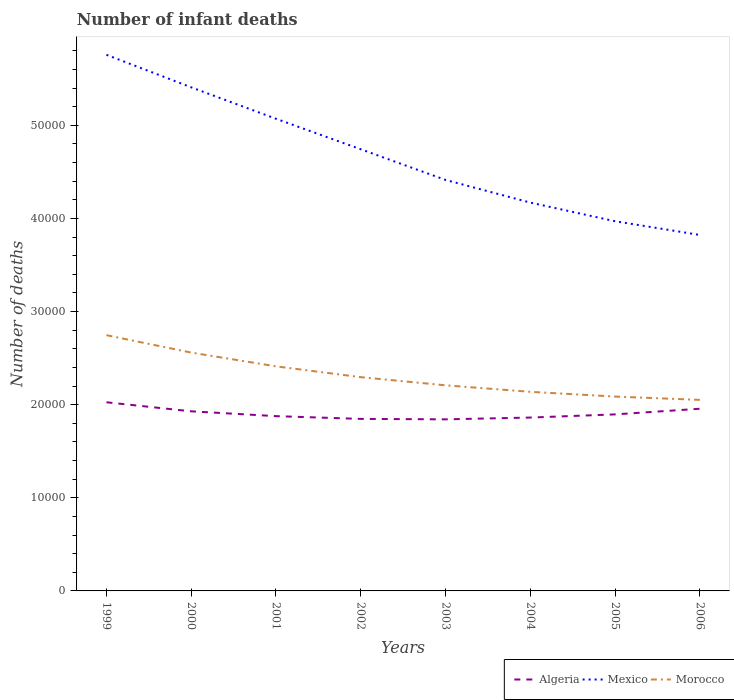How many different coloured lines are there?
Provide a succinct answer. 3. Is the number of lines equal to the number of legend labels?
Your answer should be compact. Yes. Across all years, what is the maximum number of infant deaths in Morocco?
Keep it short and to the point. 2.05e+04. What is the total number of infant deaths in Mexico in the graph?
Provide a short and direct response. 1.59e+04. What is the difference between the highest and the second highest number of infant deaths in Mexico?
Offer a very short reply. 1.93e+04. What is the difference between the highest and the lowest number of infant deaths in Morocco?
Ensure brevity in your answer.  3. How many lines are there?
Provide a short and direct response. 3. What is the difference between two consecutive major ticks on the Y-axis?
Offer a very short reply. 10000. Does the graph contain grids?
Ensure brevity in your answer.  No. How many legend labels are there?
Provide a short and direct response. 3. How are the legend labels stacked?
Ensure brevity in your answer.  Horizontal. What is the title of the graph?
Your answer should be very brief. Number of infant deaths. Does "Ghana" appear as one of the legend labels in the graph?
Your answer should be very brief. No. What is the label or title of the X-axis?
Offer a terse response. Years. What is the label or title of the Y-axis?
Your answer should be compact. Number of deaths. What is the Number of deaths of Algeria in 1999?
Give a very brief answer. 2.03e+04. What is the Number of deaths in Mexico in 1999?
Give a very brief answer. 5.76e+04. What is the Number of deaths in Morocco in 1999?
Your response must be concise. 2.75e+04. What is the Number of deaths of Algeria in 2000?
Keep it short and to the point. 1.93e+04. What is the Number of deaths of Mexico in 2000?
Keep it short and to the point. 5.41e+04. What is the Number of deaths in Morocco in 2000?
Your response must be concise. 2.56e+04. What is the Number of deaths in Algeria in 2001?
Keep it short and to the point. 1.88e+04. What is the Number of deaths in Mexico in 2001?
Your answer should be compact. 5.07e+04. What is the Number of deaths in Morocco in 2001?
Offer a very short reply. 2.41e+04. What is the Number of deaths in Algeria in 2002?
Make the answer very short. 1.85e+04. What is the Number of deaths in Mexico in 2002?
Keep it short and to the point. 4.74e+04. What is the Number of deaths in Morocco in 2002?
Make the answer very short. 2.30e+04. What is the Number of deaths in Algeria in 2003?
Ensure brevity in your answer.  1.84e+04. What is the Number of deaths in Mexico in 2003?
Make the answer very short. 4.41e+04. What is the Number of deaths in Morocco in 2003?
Provide a short and direct response. 2.21e+04. What is the Number of deaths of Algeria in 2004?
Provide a short and direct response. 1.86e+04. What is the Number of deaths of Mexico in 2004?
Provide a short and direct response. 4.17e+04. What is the Number of deaths of Morocco in 2004?
Your response must be concise. 2.14e+04. What is the Number of deaths of Algeria in 2005?
Provide a short and direct response. 1.90e+04. What is the Number of deaths of Mexico in 2005?
Ensure brevity in your answer.  3.97e+04. What is the Number of deaths of Morocco in 2005?
Provide a succinct answer. 2.09e+04. What is the Number of deaths in Algeria in 2006?
Ensure brevity in your answer.  1.96e+04. What is the Number of deaths of Mexico in 2006?
Give a very brief answer. 3.82e+04. What is the Number of deaths of Morocco in 2006?
Provide a succinct answer. 2.05e+04. Across all years, what is the maximum Number of deaths in Algeria?
Your answer should be compact. 2.03e+04. Across all years, what is the maximum Number of deaths of Mexico?
Your answer should be very brief. 5.76e+04. Across all years, what is the maximum Number of deaths of Morocco?
Offer a very short reply. 2.75e+04. Across all years, what is the minimum Number of deaths of Algeria?
Offer a terse response. 1.84e+04. Across all years, what is the minimum Number of deaths in Mexico?
Keep it short and to the point. 3.82e+04. Across all years, what is the minimum Number of deaths of Morocco?
Your answer should be very brief. 2.05e+04. What is the total Number of deaths in Algeria in the graph?
Offer a terse response. 1.52e+05. What is the total Number of deaths in Mexico in the graph?
Your response must be concise. 3.74e+05. What is the total Number of deaths of Morocco in the graph?
Give a very brief answer. 1.85e+05. What is the difference between the Number of deaths in Algeria in 1999 and that in 2000?
Keep it short and to the point. 971. What is the difference between the Number of deaths in Mexico in 1999 and that in 2000?
Offer a terse response. 3494. What is the difference between the Number of deaths in Morocco in 1999 and that in 2000?
Your response must be concise. 1869. What is the difference between the Number of deaths of Algeria in 1999 and that in 2001?
Ensure brevity in your answer.  1489. What is the difference between the Number of deaths in Mexico in 1999 and that in 2001?
Your answer should be compact. 6869. What is the difference between the Number of deaths in Morocco in 1999 and that in 2001?
Give a very brief answer. 3347. What is the difference between the Number of deaths in Algeria in 1999 and that in 2002?
Give a very brief answer. 1785. What is the difference between the Number of deaths in Mexico in 1999 and that in 2002?
Offer a terse response. 1.01e+04. What is the difference between the Number of deaths of Morocco in 1999 and that in 2002?
Offer a terse response. 4508. What is the difference between the Number of deaths in Algeria in 1999 and that in 2003?
Your response must be concise. 1833. What is the difference between the Number of deaths in Mexico in 1999 and that in 2003?
Keep it short and to the point. 1.34e+04. What is the difference between the Number of deaths of Morocco in 1999 and that in 2003?
Your answer should be very brief. 5383. What is the difference between the Number of deaths in Algeria in 1999 and that in 2004?
Keep it short and to the point. 1641. What is the difference between the Number of deaths in Mexico in 1999 and that in 2004?
Make the answer very short. 1.59e+04. What is the difference between the Number of deaths of Morocco in 1999 and that in 2004?
Your answer should be compact. 6082. What is the difference between the Number of deaths of Algeria in 1999 and that in 2005?
Provide a short and direct response. 1301. What is the difference between the Number of deaths of Mexico in 1999 and that in 2005?
Your answer should be very brief. 1.79e+04. What is the difference between the Number of deaths of Morocco in 1999 and that in 2005?
Make the answer very short. 6592. What is the difference between the Number of deaths in Algeria in 1999 and that in 2006?
Your answer should be very brief. 695. What is the difference between the Number of deaths of Mexico in 1999 and that in 2006?
Provide a short and direct response. 1.93e+04. What is the difference between the Number of deaths in Morocco in 1999 and that in 2006?
Give a very brief answer. 6949. What is the difference between the Number of deaths of Algeria in 2000 and that in 2001?
Give a very brief answer. 518. What is the difference between the Number of deaths of Mexico in 2000 and that in 2001?
Keep it short and to the point. 3375. What is the difference between the Number of deaths of Morocco in 2000 and that in 2001?
Your response must be concise. 1478. What is the difference between the Number of deaths of Algeria in 2000 and that in 2002?
Your answer should be very brief. 814. What is the difference between the Number of deaths of Mexico in 2000 and that in 2002?
Your answer should be compact. 6650. What is the difference between the Number of deaths of Morocco in 2000 and that in 2002?
Offer a terse response. 2639. What is the difference between the Number of deaths in Algeria in 2000 and that in 2003?
Give a very brief answer. 862. What is the difference between the Number of deaths in Mexico in 2000 and that in 2003?
Your answer should be compact. 9943. What is the difference between the Number of deaths in Morocco in 2000 and that in 2003?
Provide a succinct answer. 3514. What is the difference between the Number of deaths in Algeria in 2000 and that in 2004?
Offer a very short reply. 670. What is the difference between the Number of deaths of Mexico in 2000 and that in 2004?
Your response must be concise. 1.24e+04. What is the difference between the Number of deaths in Morocco in 2000 and that in 2004?
Your answer should be compact. 4213. What is the difference between the Number of deaths in Algeria in 2000 and that in 2005?
Your answer should be compact. 330. What is the difference between the Number of deaths in Mexico in 2000 and that in 2005?
Keep it short and to the point. 1.44e+04. What is the difference between the Number of deaths in Morocco in 2000 and that in 2005?
Keep it short and to the point. 4723. What is the difference between the Number of deaths of Algeria in 2000 and that in 2006?
Offer a very short reply. -276. What is the difference between the Number of deaths of Mexico in 2000 and that in 2006?
Your answer should be compact. 1.59e+04. What is the difference between the Number of deaths in Morocco in 2000 and that in 2006?
Keep it short and to the point. 5080. What is the difference between the Number of deaths of Algeria in 2001 and that in 2002?
Make the answer very short. 296. What is the difference between the Number of deaths in Mexico in 2001 and that in 2002?
Ensure brevity in your answer.  3275. What is the difference between the Number of deaths of Morocco in 2001 and that in 2002?
Your answer should be compact. 1161. What is the difference between the Number of deaths in Algeria in 2001 and that in 2003?
Make the answer very short. 344. What is the difference between the Number of deaths in Mexico in 2001 and that in 2003?
Ensure brevity in your answer.  6568. What is the difference between the Number of deaths of Morocco in 2001 and that in 2003?
Keep it short and to the point. 2036. What is the difference between the Number of deaths of Algeria in 2001 and that in 2004?
Your answer should be very brief. 152. What is the difference between the Number of deaths in Mexico in 2001 and that in 2004?
Give a very brief answer. 9003. What is the difference between the Number of deaths in Morocco in 2001 and that in 2004?
Keep it short and to the point. 2735. What is the difference between the Number of deaths in Algeria in 2001 and that in 2005?
Your answer should be very brief. -188. What is the difference between the Number of deaths in Mexico in 2001 and that in 2005?
Ensure brevity in your answer.  1.10e+04. What is the difference between the Number of deaths of Morocco in 2001 and that in 2005?
Ensure brevity in your answer.  3245. What is the difference between the Number of deaths in Algeria in 2001 and that in 2006?
Provide a succinct answer. -794. What is the difference between the Number of deaths of Mexico in 2001 and that in 2006?
Give a very brief answer. 1.25e+04. What is the difference between the Number of deaths in Morocco in 2001 and that in 2006?
Your response must be concise. 3602. What is the difference between the Number of deaths in Algeria in 2002 and that in 2003?
Provide a succinct answer. 48. What is the difference between the Number of deaths of Mexico in 2002 and that in 2003?
Provide a short and direct response. 3293. What is the difference between the Number of deaths of Morocco in 2002 and that in 2003?
Ensure brevity in your answer.  875. What is the difference between the Number of deaths in Algeria in 2002 and that in 2004?
Your answer should be very brief. -144. What is the difference between the Number of deaths of Mexico in 2002 and that in 2004?
Ensure brevity in your answer.  5728. What is the difference between the Number of deaths of Morocco in 2002 and that in 2004?
Offer a terse response. 1574. What is the difference between the Number of deaths of Algeria in 2002 and that in 2005?
Offer a very short reply. -484. What is the difference between the Number of deaths in Mexico in 2002 and that in 2005?
Ensure brevity in your answer.  7730. What is the difference between the Number of deaths in Morocco in 2002 and that in 2005?
Give a very brief answer. 2084. What is the difference between the Number of deaths in Algeria in 2002 and that in 2006?
Offer a terse response. -1090. What is the difference between the Number of deaths of Mexico in 2002 and that in 2006?
Your answer should be compact. 9204. What is the difference between the Number of deaths in Morocco in 2002 and that in 2006?
Offer a terse response. 2441. What is the difference between the Number of deaths in Algeria in 2003 and that in 2004?
Keep it short and to the point. -192. What is the difference between the Number of deaths of Mexico in 2003 and that in 2004?
Your answer should be compact. 2435. What is the difference between the Number of deaths of Morocco in 2003 and that in 2004?
Make the answer very short. 699. What is the difference between the Number of deaths of Algeria in 2003 and that in 2005?
Give a very brief answer. -532. What is the difference between the Number of deaths of Mexico in 2003 and that in 2005?
Your answer should be compact. 4437. What is the difference between the Number of deaths in Morocco in 2003 and that in 2005?
Provide a short and direct response. 1209. What is the difference between the Number of deaths of Algeria in 2003 and that in 2006?
Provide a short and direct response. -1138. What is the difference between the Number of deaths of Mexico in 2003 and that in 2006?
Offer a very short reply. 5911. What is the difference between the Number of deaths in Morocco in 2003 and that in 2006?
Give a very brief answer. 1566. What is the difference between the Number of deaths in Algeria in 2004 and that in 2005?
Keep it short and to the point. -340. What is the difference between the Number of deaths in Mexico in 2004 and that in 2005?
Keep it short and to the point. 2002. What is the difference between the Number of deaths of Morocco in 2004 and that in 2005?
Your response must be concise. 510. What is the difference between the Number of deaths in Algeria in 2004 and that in 2006?
Offer a very short reply. -946. What is the difference between the Number of deaths in Mexico in 2004 and that in 2006?
Make the answer very short. 3476. What is the difference between the Number of deaths of Morocco in 2004 and that in 2006?
Make the answer very short. 867. What is the difference between the Number of deaths of Algeria in 2005 and that in 2006?
Ensure brevity in your answer.  -606. What is the difference between the Number of deaths of Mexico in 2005 and that in 2006?
Your response must be concise. 1474. What is the difference between the Number of deaths of Morocco in 2005 and that in 2006?
Ensure brevity in your answer.  357. What is the difference between the Number of deaths in Algeria in 1999 and the Number of deaths in Mexico in 2000?
Your answer should be very brief. -3.38e+04. What is the difference between the Number of deaths in Algeria in 1999 and the Number of deaths in Morocco in 2000?
Give a very brief answer. -5336. What is the difference between the Number of deaths of Mexico in 1999 and the Number of deaths of Morocco in 2000?
Offer a very short reply. 3.20e+04. What is the difference between the Number of deaths of Algeria in 1999 and the Number of deaths of Mexico in 2001?
Provide a succinct answer. -3.04e+04. What is the difference between the Number of deaths of Algeria in 1999 and the Number of deaths of Morocco in 2001?
Your answer should be very brief. -3858. What is the difference between the Number of deaths of Mexico in 1999 and the Number of deaths of Morocco in 2001?
Offer a terse response. 3.35e+04. What is the difference between the Number of deaths in Algeria in 1999 and the Number of deaths in Mexico in 2002?
Provide a succinct answer. -2.72e+04. What is the difference between the Number of deaths in Algeria in 1999 and the Number of deaths in Morocco in 2002?
Offer a terse response. -2697. What is the difference between the Number of deaths of Mexico in 1999 and the Number of deaths of Morocco in 2002?
Offer a very short reply. 3.46e+04. What is the difference between the Number of deaths in Algeria in 1999 and the Number of deaths in Mexico in 2003?
Your answer should be very brief. -2.39e+04. What is the difference between the Number of deaths of Algeria in 1999 and the Number of deaths of Morocco in 2003?
Make the answer very short. -1822. What is the difference between the Number of deaths in Mexico in 1999 and the Number of deaths in Morocco in 2003?
Give a very brief answer. 3.55e+04. What is the difference between the Number of deaths in Algeria in 1999 and the Number of deaths in Mexico in 2004?
Offer a very short reply. -2.14e+04. What is the difference between the Number of deaths of Algeria in 1999 and the Number of deaths of Morocco in 2004?
Make the answer very short. -1123. What is the difference between the Number of deaths in Mexico in 1999 and the Number of deaths in Morocco in 2004?
Keep it short and to the point. 3.62e+04. What is the difference between the Number of deaths in Algeria in 1999 and the Number of deaths in Mexico in 2005?
Ensure brevity in your answer.  -1.94e+04. What is the difference between the Number of deaths in Algeria in 1999 and the Number of deaths in Morocco in 2005?
Your answer should be very brief. -613. What is the difference between the Number of deaths of Mexico in 1999 and the Number of deaths of Morocco in 2005?
Offer a very short reply. 3.67e+04. What is the difference between the Number of deaths in Algeria in 1999 and the Number of deaths in Mexico in 2006?
Your answer should be compact. -1.80e+04. What is the difference between the Number of deaths of Algeria in 1999 and the Number of deaths of Morocco in 2006?
Provide a short and direct response. -256. What is the difference between the Number of deaths in Mexico in 1999 and the Number of deaths in Morocco in 2006?
Keep it short and to the point. 3.71e+04. What is the difference between the Number of deaths in Algeria in 2000 and the Number of deaths in Mexico in 2001?
Make the answer very short. -3.14e+04. What is the difference between the Number of deaths of Algeria in 2000 and the Number of deaths of Morocco in 2001?
Offer a terse response. -4829. What is the difference between the Number of deaths in Mexico in 2000 and the Number of deaths in Morocco in 2001?
Ensure brevity in your answer.  3.00e+04. What is the difference between the Number of deaths of Algeria in 2000 and the Number of deaths of Mexico in 2002?
Make the answer very short. -2.81e+04. What is the difference between the Number of deaths of Algeria in 2000 and the Number of deaths of Morocco in 2002?
Your response must be concise. -3668. What is the difference between the Number of deaths of Mexico in 2000 and the Number of deaths of Morocco in 2002?
Ensure brevity in your answer.  3.11e+04. What is the difference between the Number of deaths of Algeria in 2000 and the Number of deaths of Mexico in 2003?
Your answer should be compact. -2.49e+04. What is the difference between the Number of deaths of Algeria in 2000 and the Number of deaths of Morocco in 2003?
Make the answer very short. -2793. What is the difference between the Number of deaths in Mexico in 2000 and the Number of deaths in Morocco in 2003?
Your answer should be compact. 3.20e+04. What is the difference between the Number of deaths in Algeria in 2000 and the Number of deaths in Mexico in 2004?
Keep it short and to the point. -2.24e+04. What is the difference between the Number of deaths of Algeria in 2000 and the Number of deaths of Morocco in 2004?
Your answer should be compact. -2094. What is the difference between the Number of deaths in Mexico in 2000 and the Number of deaths in Morocco in 2004?
Give a very brief answer. 3.27e+04. What is the difference between the Number of deaths of Algeria in 2000 and the Number of deaths of Mexico in 2005?
Your answer should be compact. -2.04e+04. What is the difference between the Number of deaths in Algeria in 2000 and the Number of deaths in Morocco in 2005?
Your response must be concise. -1584. What is the difference between the Number of deaths of Mexico in 2000 and the Number of deaths of Morocco in 2005?
Give a very brief answer. 3.32e+04. What is the difference between the Number of deaths of Algeria in 2000 and the Number of deaths of Mexico in 2006?
Offer a terse response. -1.89e+04. What is the difference between the Number of deaths in Algeria in 2000 and the Number of deaths in Morocco in 2006?
Ensure brevity in your answer.  -1227. What is the difference between the Number of deaths of Mexico in 2000 and the Number of deaths of Morocco in 2006?
Your response must be concise. 3.36e+04. What is the difference between the Number of deaths in Algeria in 2001 and the Number of deaths in Mexico in 2002?
Provide a succinct answer. -2.87e+04. What is the difference between the Number of deaths in Algeria in 2001 and the Number of deaths in Morocco in 2002?
Make the answer very short. -4186. What is the difference between the Number of deaths in Mexico in 2001 and the Number of deaths in Morocco in 2002?
Your response must be concise. 2.78e+04. What is the difference between the Number of deaths in Algeria in 2001 and the Number of deaths in Mexico in 2003?
Ensure brevity in your answer.  -2.54e+04. What is the difference between the Number of deaths in Algeria in 2001 and the Number of deaths in Morocco in 2003?
Keep it short and to the point. -3311. What is the difference between the Number of deaths of Mexico in 2001 and the Number of deaths of Morocco in 2003?
Ensure brevity in your answer.  2.86e+04. What is the difference between the Number of deaths of Algeria in 2001 and the Number of deaths of Mexico in 2004?
Offer a terse response. -2.29e+04. What is the difference between the Number of deaths of Algeria in 2001 and the Number of deaths of Morocco in 2004?
Your response must be concise. -2612. What is the difference between the Number of deaths of Mexico in 2001 and the Number of deaths of Morocco in 2004?
Offer a very short reply. 2.93e+04. What is the difference between the Number of deaths in Algeria in 2001 and the Number of deaths in Mexico in 2005?
Ensure brevity in your answer.  -2.09e+04. What is the difference between the Number of deaths in Algeria in 2001 and the Number of deaths in Morocco in 2005?
Give a very brief answer. -2102. What is the difference between the Number of deaths of Mexico in 2001 and the Number of deaths of Morocco in 2005?
Your answer should be very brief. 2.98e+04. What is the difference between the Number of deaths of Algeria in 2001 and the Number of deaths of Mexico in 2006?
Offer a very short reply. -1.95e+04. What is the difference between the Number of deaths in Algeria in 2001 and the Number of deaths in Morocco in 2006?
Keep it short and to the point. -1745. What is the difference between the Number of deaths in Mexico in 2001 and the Number of deaths in Morocco in 2006?
Offer a very short reply. 3.02e+04. What is the difference between the Number of deaths of Algeria in 2002 and the Number of deaths of Mexico in 2003?
Your response must be concise. -2.57e+04. What is the difference between the Number of deaths of Algeria in 2002 and the Number of deaths of Morocco in 2003?
Your response must be concise. -3607. What is the difference between the Number of deaths in Mexico in 2002 and the Number of deaths in Morocco in 2003?
Your response must be concise. 2.54e+04. What is the difference between the Number of deaths in Algeria in 2002 and the Number of deaths in Mexico in 2004?
Provide a succinct answer. -2.32e+04. What is the difference between the Number of deaths in Algeria in 2002 and the Number of deaths in Morocco in 2004?
Your answer should be very brief. -2908. What is the difference between the Number of deaths in Mexico in 2002 and the Number of deaths in Morocco in 2004?
Give a very brief answer. 2.60e+04. What is the difference between the Number of deaths in Algeria in 2002 and the Number of deaths in Mexico in 2005?
Keep it short and to the point. -2.12e+04. What is the difference between the Number of deaths of Algeria in 2002 and the Number of deaths of Morocco in 2005?
Your answer should be very brief. -2398. What is the difference between the Number of deaths of Mexico in 2002 and the Number of deaths of Morocco in 2005?
Make the answer very short. 2.66e+04. What is the difference between the Number of deaths of Algeria in 2002 and the Number of deaths of Mexico in 2006?
Make the answer very short. -1.98e+04. What is the difference between the Number of deaths of Algeria in 2002 and the Number of deaths of Morocco in 2006?
Make the answer very short. -2041. What is the difference between the Number of deaths of Mexico in 2002 and the Number of deaths of Morocco in 2006?
Ensure brevity in your answer.  2.69e+04. What is the difference between the Number of deaths of Algeria in 2003 and the Number of deaths of Mexico in 2004?
Your response must be concise. -2.33e+04. What is the difference between the Number of deaths in Algeria in 2003 and the Number of deaths in Morocco in 2004?
Give a very brief answer. -2956. What is the difference between the Number of deaths of Mexico in 2003 and the Number of deaths of Morocco in 2004?
Your answer should be very brief. 2.28e+04. What is the difference between the Number of deaths in Algeria in 2003 and the Number of deaths in Mexico in 2005?
Provide a short and direct response. -2.13e+04. What is the difference between the Number of deaths of Algeria in 2003 and the Number of deaths of Morocco in 2005?
Give a very brief answer. -2446. What is the difference between the Number of deaths of Mexico in 2003 and the Number of deaths of Morocco in 2005?
Provide a succinct answer. 2.33e+04. What is the difference between the Number of deaths of Algeria in 2003 and the Number of deaths of Mexico in 2006?
Keep it short and to the point. -1.98e+04. What is the difference between the Number of deaths of Algeria in 2003 and the Number of deaths of Morocco in 2006?
Provide a short and direct response. -2089. What is the difference between the Number of deaths of Mexico in 2003 and the Number of deaths of Morocco in 2006?
Ensure brevity in your answer.  2.36e+04. What is the difference between the Number of deaths in Algeria in 2004 and the Number of deaths in Mexico in 2005?
Your answer should be compact. -2.11e+04. What is the difference between the Number of deaths in Algeria in 2004 and the Number of deaths in Morocco in 2005?
Ensure brevity in your answer.  -2254. What is the difference between the Number of deaths of Mexico in 2004 and the Number of deaths of Morocco in 2005?
Your answer should be very brief. 2.08e+04. What is the difference between the Number of deaths in Algeria in 2004 and the Number of deaths in Mexico in 2006?
Offer a terse response. -1.96e+04. What is the difference between the Number of deaths in Algeria in 2004 and the Number of deaths in Morocco in 2006?
Ensure brevity in your answer.  -1897. What is the difference between the Number of deaths of Mexico in 2004 and the Number of deaths of Morocco in 2006?
Provide a short and direct response. 2.12e+04. What is the difference between the Number of deaths in Algeria in 2005 and the Number of deaths in Mexico in 2006?
Your answer should be compact. -1.93e+04. What is the difference between the Number of deaths in Algeria in 2005 and the Number of deaths in Morocco in 2006?
Your answer should be compact. -1557. What is the difference between the Number of deaths in Mexico in 2005 and the Number of deaths in Morocco in 2006?
Your answer should be very brief. 1.92e+04. What is the average Number of deaths in Algeria per year?
Offer a very short reply. 1.90e+04. What is the average Number of deaths of Mexico per year?
Provide a succinct answer. 4.67e+04. What is the average Number of deaths of Morocco per year?
Offer a very short reply. 2.31e+04. In the year 1999, what is the difference between the Number of deaths of Algeria and Number of deaths of Mexico?
Keep it short and to the point. -3.73e+04. In the year 1999, what is the difference between the Number of deaths in Algeria and Number of deaths in Morocco?
Make the answer very short. -7205. In the year 1999, what is the difference between the Number of deaths of Mexico and Number of deaths of Morocco?
Make the answer very short. 3.01e+04. In the year 2000, what is the difference between the Number of deaths in Algeria and Number of deaths in Mexico?
Keep it short and to the point. -3.48e+04. In the year 2000, what is the difference between the Number of deaths of Algeria and Number of deaths of Morocco?
Your answer should be very brief. -6307. In the year 2000, what is the difference between the Number of deaths in Mexico and Number of deaths in Morocco?
Provide a short and direct response. 2.85e+04. In the year 2001, what is the difference between the Number of deaths of Algeria and Number of deaths of Mexico?
Provide a short and direct response. -3.19e+04. In the year 2001, what is the difference between the Number of deaths in Algeria and Number of deaths in Morocco?
Your answer should be compact. -5347. In the year 2001, what is the difference between the Number of deaths of Mexico and Number of deaths of Morocco?
Your answer should be very brief. 2.66e+04. In the year 2002, what is the difference between the Number of deaths of Algeria and Number of deaths of Mexico?
Your response must be concise. -2.90e+04. In the year 2002, what is the difference between the Number of deaths in Algeria and Number of deaths in Morocco?
Provide a succinct answer. -4482. In the year 2002, what is the difference between the Number of deaths in Mexico and Number of deaths in Morocco?
Offer a very short reply. 2.45e+04. In the year 2003, what is the difference between the Number of deaths of Algeria and Number of deaths of Mexico?
Your response must be concise. -2.57e+04. In the year 2003, what is the difference between the Number of deaths in Algeria and Number of deaths in Morocco?
Provide a succinct answer. -3655. In the year 2003, what is the difference between the Number of deaths in Mexico and Number of deaths in Morocco?
Provide a short and direct response. 2.21e+04. In the year 2004, what is the difference between the Number of deaths of Algeria and Number of deaths of Mexico?
Offer a terse response. -2.31e+04. In the year 2004, what is the difference between the Number of deaths in Algeria and Number of deaths in Morocco?
Your response must be concise. -2764. In the year 2004, what is the difference between the Number of deaths in Mexico and Number of deaths in Morocco?
Ensure brevity in your answer.  2.03e+04. In the year 2005, what is the difference between the Number of deaths in Algeria and Number of deaths in Mexico?
Provide a succinct answer. -2.07e+04. In the year 2005, what is the difference between the Number of deaths in Algeria and Number of deaths in Morocco?
Keep it short and to the point. -1914. In the year 2005, what is the difference between the Number of deaths in Mexico and Number of deaths in Morocco?
Your response must be concise. 1.88e+04. In the year 2006, what is the difference between the Number of deaths in Algeria and Number of deaths in Mexico?
Offer a very short reply. -1.87e+04. In the year 2006, what is the difference between the Number of deaths in Algeria and Number of deaths in Morocco?
Provide a short and direct response. -951. In the year 2006, what is the difference between the Number of deaths in Mexico and Number of deaths in Morocco?
Offer a terse response. 1.77e+04. What is the ratio of the Number of deaths in Algeria in 1999 to that in 2000?
Provide a succinct answer. 1.05. What is the ratio of the Number of deaths of Mexico in 1999 to that in 2000?
Offer a very short reply. 1.06. What is the ratio of the Number of deaths in Morocco in 1999 to that in 2000?
Offer a terse response. 1.07. What is the ratio of the Number of deaths of Algeria in 1999 to that in 2001?
Offer a terse response. 1.08. What is the ratio of the Number of deaths in Mexico in 1999 to that in 2001?
Provide a succinct answer. 1.14. What is the ratio of the Number of deaths of Morocco in 1999 to that in 2001?
Provide a succinct answer. 1.14. What is the ratio of the Number of deaths of Algeria in 1999 to that in 2002?
Provide a succinct answer. 1.1. What is the ratio of the Number of deaths of Mexico in 1999 to that in 2002?
Give a very brief answer. 1.21. What is the ratio of the Number of deaths of Morocco in 1999 to that in 2002?
Give a very brief answer. 1.2. What is the ratio of the Number of deaths of Algeria in 1999 to that in 2003?
Provide a succinct answer. 1.1. What is the ratio of the Number of deaths of Mexico in 1999 to that in 2003?
Your answer should be very brief. 1.3. What is the ratio of the Number of deaths of Morocco in 1999 to that in 2003?
Give a very brief answer. 1.24. What is the ratio of the Number of deaths in Algeria in 1999 to that in 2004?
Make the answer very short. 1.09. What is the ratio of the Number of deaths of Mexico in 1999 to that in 2004?
Give a very brief answer. 1.38. What is the ratio of the Number of deaths in Morocco in 1999 to that in 2004?
Offer a very short reply. 1.28. What is the ratio of the Number of deaths in Algeria in 1999 to that in 2005?
Provide a succinct answer. 1.07. What is the ratio of the Number of deaths in Mexico in 1999 to that in 2005?
Offer a terse response. 1.45. What is the ratio of the Number of deaths in Morocco in 1999 to that in 2005?
Your answer should be very brief. 1.32. What is the ratio of the Number of deaths of Algeria in 1999 to that in 2006?
Keep it short and to the point. 1.04. What is the ratio of the Number of deaths in Mexico in 1999 to that in 2006?
Provide a short and direct response. 1.51. What is the ratio of the Number of deaths in Morocco in 1999 to that in 2006?
Your answer should be compact. 1.34. What is the ratio of the Number of deaths in Algeria in 2000 to that in 2001?
Your answer should be very brief. 1.03. What is the ratio of the Number of deaths in Mexico in 2000 to that in 2001?
Offer a very short reply. 1.07. What is the ratio of the Number of deaths of Morocco in 2000 to that in 2001?
Offer a terse response. 1.06. What is the ratio of the Number of deaths of Algeria in 2000 to that in 2002?
Give a very brief answer. 1.04. What is the ratio of the Number of deaths in Mexico in 2000 to that in 2002?
Your response must be concise. 1.14. What is the ratio of the Number of deaths of Morocco in 2000 to that in 2002?
Keep it short and to the point. 1.11. What is the ratio of the Number of deaths of Algeria in 2000 to that in 2003?
Ensure brevity in your answer.  1.05. What is the ratio of the Number of deaths in Mexico in 2000 to that in 2003?
Provide a succinct answer. 1.23. What is the ratio of the Number of deaths of Morocco in 2000 to that in 2003?
Keep it short and to the point. 1.16. What is the ratio of the Number of deaths of Algeria in 2000 to that in 2004?
Your answer should be very brief. 1.04. What is the ratio of the Number of deaths of Mexico in 2000 to that in 2004?
Your response must be concise. 1.3. What is the ratio of the Number of deaths of Morocco in 2000 to that in 2004?
Ensure brevity in your answer.  1.2. What is the ratio of the Number of deaths in Algeria in 2000 to that in 2005?
Keep it short and to the point. 1.02. What is the ratio of the Number of deaths of Mexico in 2000 to that in 2005?
Provide a short and direct response. 1.36. What is the ratio of the Number of deaths in Morocco in 2000 to that in 2005?
Give a very brief answer. 1.23. What is the ratio of the Number of deaths in Algeria in 2000 to that in 2006?
Make the answer very short. 0.99. What is the ratio of the Number of deaths in Mexico in 2000 to that in 2006?
Keep it short and to the point. 1.41. What is the ratio of the Number of deaths in Morocco in 2000 to that in 2006?
Your answer should be compact. 1.25. What is the ratio of the Number of deaths in Mexico in 2001 to that in 2002?
Offer a terse response. 1.07. What is the ratio of the Number of deaths of Morocco in 2001 to that in 2002?
Offer a very short reply. 1.05. What is the ratio of the Number of deaths of Algeria in 2001 to that in 2003?
Make the answer very short. 1.02. What is the ratio of the Number of deaths of Mexico in 2001 to that in 2003?
Offer a very short reply. 1.15. What is the ratio of the Number of deaths in Morocco in 2001 to that in 2003?
Give a very brief answer. 1.09. What is the ratio of the Number of deaths in Algeria in 2001 to that in 2004?
Your answer should be very brief. 1.01. What is the ratio of the Number of deaths of Mexico in 2001 to that in 2004?
Ensure brevity in your answer.  1.22. What is the ratio of the Number of deaths of Morocco in 2001 to that in 2004?
Provide a succinct answer. 1.13. What is the ratio of the Number of deaths in Algeria in 2001 to that in 2005?
Ensure brevity in your answer.  0.99. What is the ratio of the Number of deaths in Mexico in 2001 to that in 2005?
Provide a succinct answer. 1.28. What is the ratio of the Number of deaths in Morocco in 2001 to that in 2005?
Provide a succinct answer. 1.16. What is the ratio of the Number of deaths in Algeria in 2001 to that in 2006?
Your answer should be very brief. 0.96. What is the ratio of the Number of deaths in Mexico in 2001 to that in 2006?
Offer a very short reply. 1.33. What is the ratio of the Number of deaths in Morocco in 2001 to that in 2006?
Your response must be concise. 1.18. What is the ratio of the Number of deaths of Mexico in 2002 to that in 2003?
Keep it short and to the point. 1.07. What is the ratio of the Number of deaths of Morocco in 2002 to that in 2003?
Your response must be concise. 1.04. What is the ratio of the Number of deaths of Mexico in 2002 to that in 2004?
Offer a very short reply. 1.14. What is the ratio of the Number of deaths in Morocco in 2002 to that in 2004?
Make the answer very short. 1.07. What is the ratio of the Number of deaths of Algeria in 2002 to that in 2005?
Your response must be concise. 0.97. What is the ratio of the Number of deaths of Mexico in 2002 to that in 2005?
Your answer should be very brief. 1.19. What is the ratio of the Number of deaths in Morocco in 2002 to that in 2005?
Offer a terse response. 1.1. What is the ratio of the Number of deaths in Algeria in 2002 to that in 2006?
Provide a short and direct response. 0.94. What is the ratio of the Number of deaths in Mexico in 2002 to that in 2006?
Offer a terse response. 1.24. What is the ratio of the Number of deaths of Morocco in 2002 to that in 2006?
Offer a very short reply. 1.12. What is the ratio of the Number of deaths of Mexico in 2003 to that in 2004?
Make the answer very short. 1.06. What is the ratio of the Number of deaths in Morocco in 2003 to that in 2004?
Your answer should be very brief. 1.03. What is the ratio of the Number of deaths in Algeria in 2003 to that in 2005?
Your answer should be compact. 0.97. What is the ratio of the Number of deaths of Mexico in 2003 to that in 2005?
Your answer should be very brief. 1.11. What is the ratio of the Number of deaths of Morocco in 2003 to that in 2005?
Make the answer very short. 1.06. What is the ratio of the Number of deaths in Algeria in 2003 to that in 2006?
Provide a succinct answer. 0.94. What is the ratio of the Number of deaths in Mexico in 2003 to that in 2006?
Offer a very short reply. 1.15. What is the ratio of the Number of deaths of Morocco in 2003 to that in 2006?
Make the answer very short. 1.08. What is the ratio of the Number of deaths of Algeria in 2004 to that in 2005?
Provide a succinct answer. 0.98. What is the ratio of the Number of deaths of Mexico in 2004 to that in 2005?
Ensure brevity in your answer.  1.05. What is the ratio of the Number of deaths of Morocco in 2004 to that in 2005?
Keep it short and to the point. 1.02. What is the ratio of the Number of deaths of Algeria in 2004 to that in 2006?
Offer a terse response. 0.95. What is the ratio of the Number of deaths of Mexico in 2004 to that in 2006?
Make the answer very short. 1.09. What is the ratio of the Number of deaths of Morocco in 2004 to that in 2006?
Offer a terse response. 1.04. What is the ratio of the Number of deaths of Algeria in 2005 to that in 2006?
Your response must be concise. 0.97. What is the ratio of the Number of deaths of Mexico in 2005 to that in 2006?
Make the answer very short. 1.04. What is the ratio of the Number of deaths of Morocco in 2005 to that in 2006?
Offer a very short reply. 1.02. What is the difference between the highest and the second highest Number of deaths of Algeria?
Your answer should be compact. 695. What is the difference between the highest and the second highest Number of deaths in Mexico?
Provide a succinct answer. 3494. What is the difference between the highest and the second highest Number of deaths in Morocco?
Provide a short and direct response. 1869. What is the difference between the highest and the lowest Number of deaths of Algeria?
Provide a short and direct response. 1833. What is the difference between the highest and the lowest Number of deaths in Mexico?
Your answer should be compact. 1.93e+04. What is the difference between the highest and the lowest Number of deaths of Morocco?
Your answer should be very brief. 6949. 